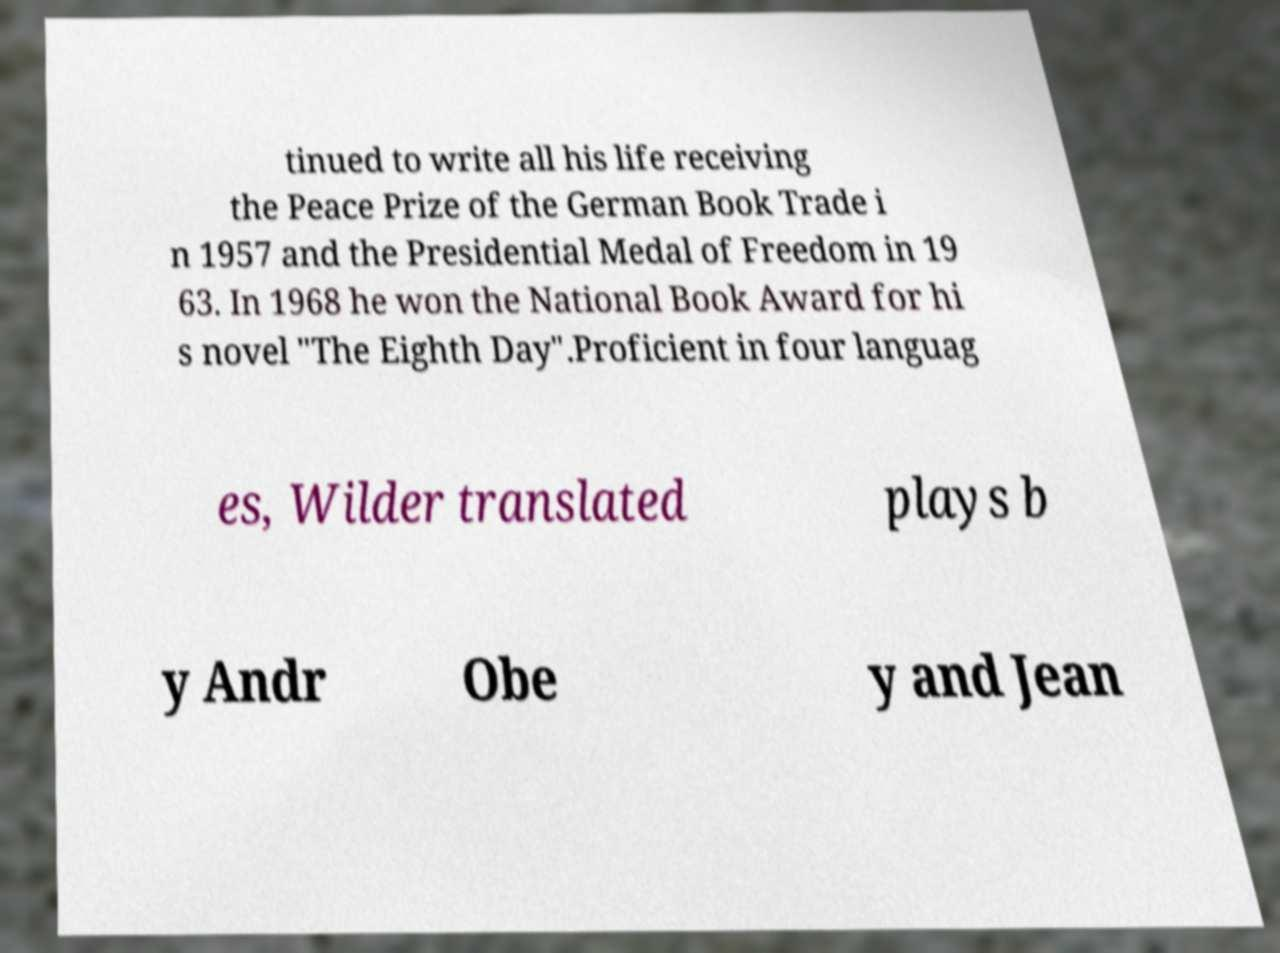Can you read and provide the text displayed in the image?This photo seems to have some interesting text. Can you extract and type it out for me? tinued to write all his life receiving the Peace Prize of the German Book Trade i n 1957 and the Presidential Medal of Freedom in 19 63. In 1968 he won the National Book Award for hi s novel "The Eighth Day".Proficient in four languag es, Wilder translated plays b y Andr Obe y and Jean 